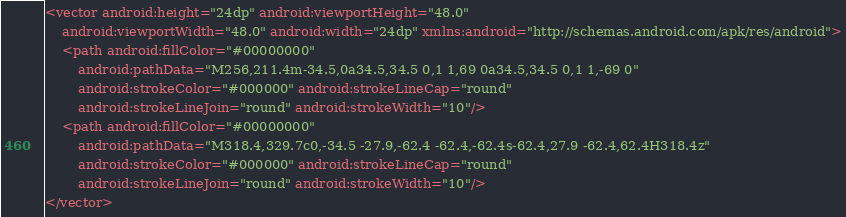<code> <loc_0><loc_0><loc_500><loc_500><_XML_><vector android:height="24dp" android:viewportHeight="48.0"
    android:viewportWidth="48.0" android:width="24dp" xmlns:android="http://schemas.android.com/apk/res/android">
    <path android:fillColor="#00000000"
        android:pathData="M256,211.4m-34.5,0a34.5,34.5 0,1 1,69 0a34.5,34.5 0,1 1,-69 0"
        android:strokeColor="#000000" android:strokeLineCap="round"
        android:strokeLineJoin="round" android:strokeWidth="10"/>
    <path android:fillColor="#00000000"
        android:pathData="M318.4,329.7c0,-34.5 -27.9,-62.4 -62.4,-62.4s-62.4,27.9 -62.4,62.4H318.4z"
        android:strokeColor="#000000" android:strokeLineCap="round"
        android:strokeLineJoin="round" android:strokeWidth="10"/>
</vector>
</code> 